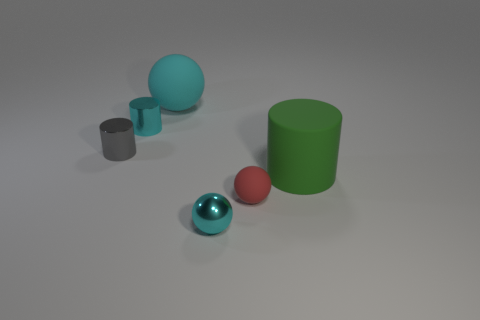Are there the same number of small gray objects that are to the right of the red object and small green matte cylinders?
Provide a succinct answer. Yes. Is there a small cylinder that has the same color as the shiny ball?
Offer a very short reply. Yes. Do the shiny sphere and the cyan metal cylinder have the same size?
Your response must be concise. Yes. What size is the cyan ball that is in front of the matte thing behind the small gray shiny object?
Offer a terse response. Small. There is a cyan object that is both in front of the big cyan matte ball and behind the tiny rubber sphere; how big is it?
Provide a short and direct response. Small. What number of green matte cylinders have the same size as the gray cylinder?
Provide a succinct answer. 0. How many shiny things are either small red things or gray cylinders?
Give a very brief answer. 1. What size is the cylinder that is the same color as the big rubber ball?
Provide a succinct answer. Small. There is a cyan sphere to the left of the tiny shiny ball in front of the cyan rubber thing; what is it made of?
Ensure brevity in your answer.  Rubber. How many things are either cyan spheres or cyan balls behind the cyan cylinder?
Provide a short and direct response. 2. 